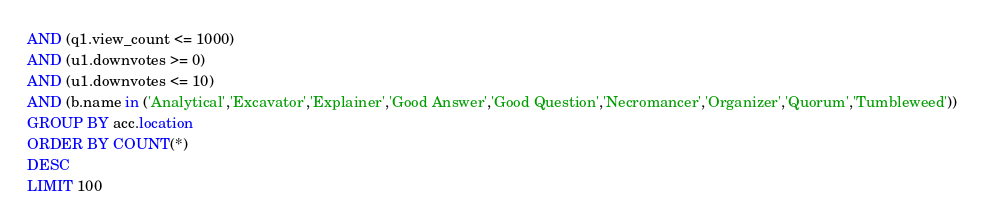<code> <loc_0><loc_0><loc_500><loc_500><_SQL_>AND (q1.view_count <= 1000)
AND (u1.downvotes >= 0)
AND (u1.downvotes <= 10)
AND (b.name in ('Analytical','Excavator','Explainer','Good Answer','Good Question','Necromancer','Organizer','Quorum','Tumbleweed'))
GROUP BY acc.location
ORDER BY COUNT(*)
DESC
LIMIT 100
</code> 